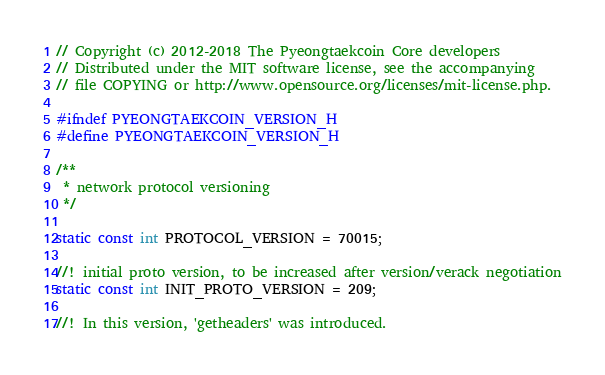<code> <loc_0><loc_0><loc_500><loc_500><_C_>// Copyright (c) 2012-2018 The Pyeongtaekcoin Core developers
// Distributed under the MIT software license, see the accompanying
// file COPYING or http://www.opensource.org/licenses/mit-license.php.

#ifndef PYEONGTAEKCOIN_VERSION_H
#define PYEONGTAEKCOIN_VERSION_H

/**
 * network protocol versioning
 */

static const int PROTOCOL_VERSION = 70015;

//! initial proto version, to be increased after version/verack negotiation
static const int INIT_PROTO_VERSION = 209;

//! In this version, 'getheaders' was introduced.</code> 